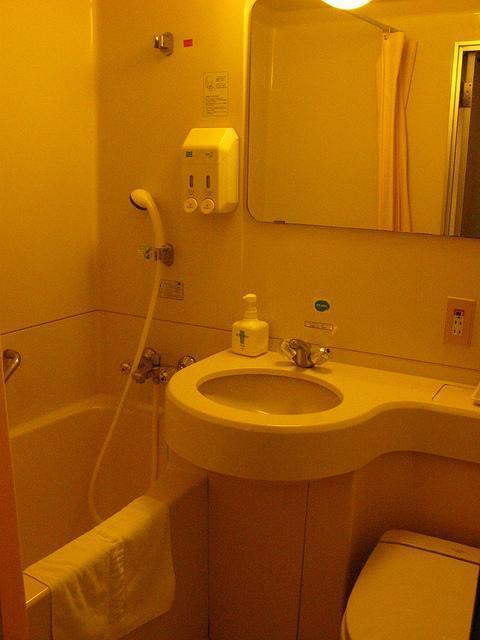How many toilets can be seen?
Give a very brief answer. 1. 